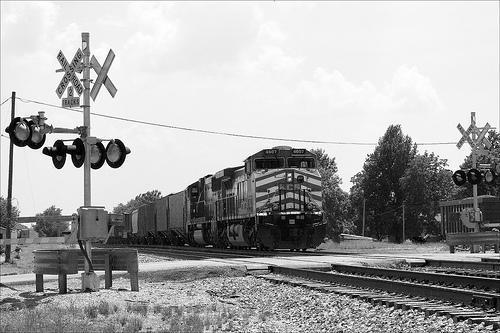How many trains are seen?
Give a very brief answer. 1. 